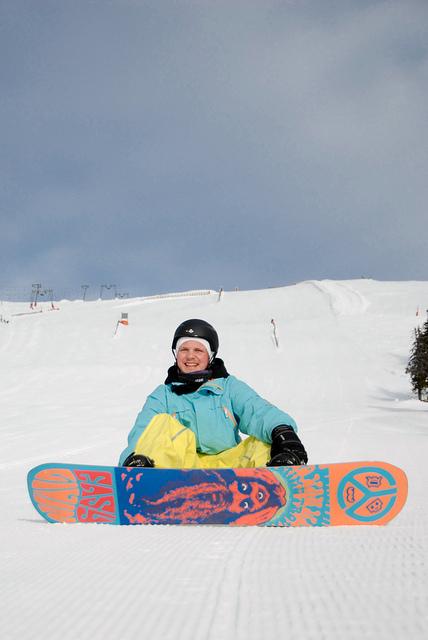What is on this person's feet?
Give a very brief answer. Snowboard. What sport is this man doing?
Concise answer only. Snowboarding. What is the man doing?
Be succinct. Snowboarding. What color is the bottom of the board?
Short answer required. Red blue. What season is depicted in the image?
Answer briefly. Winter. Did that woman hurt herself?
Answer briefly. No. Did they fall?
Give a very brief answer. Yes. What does the snowboard say?
Keep it brief. Easy. 